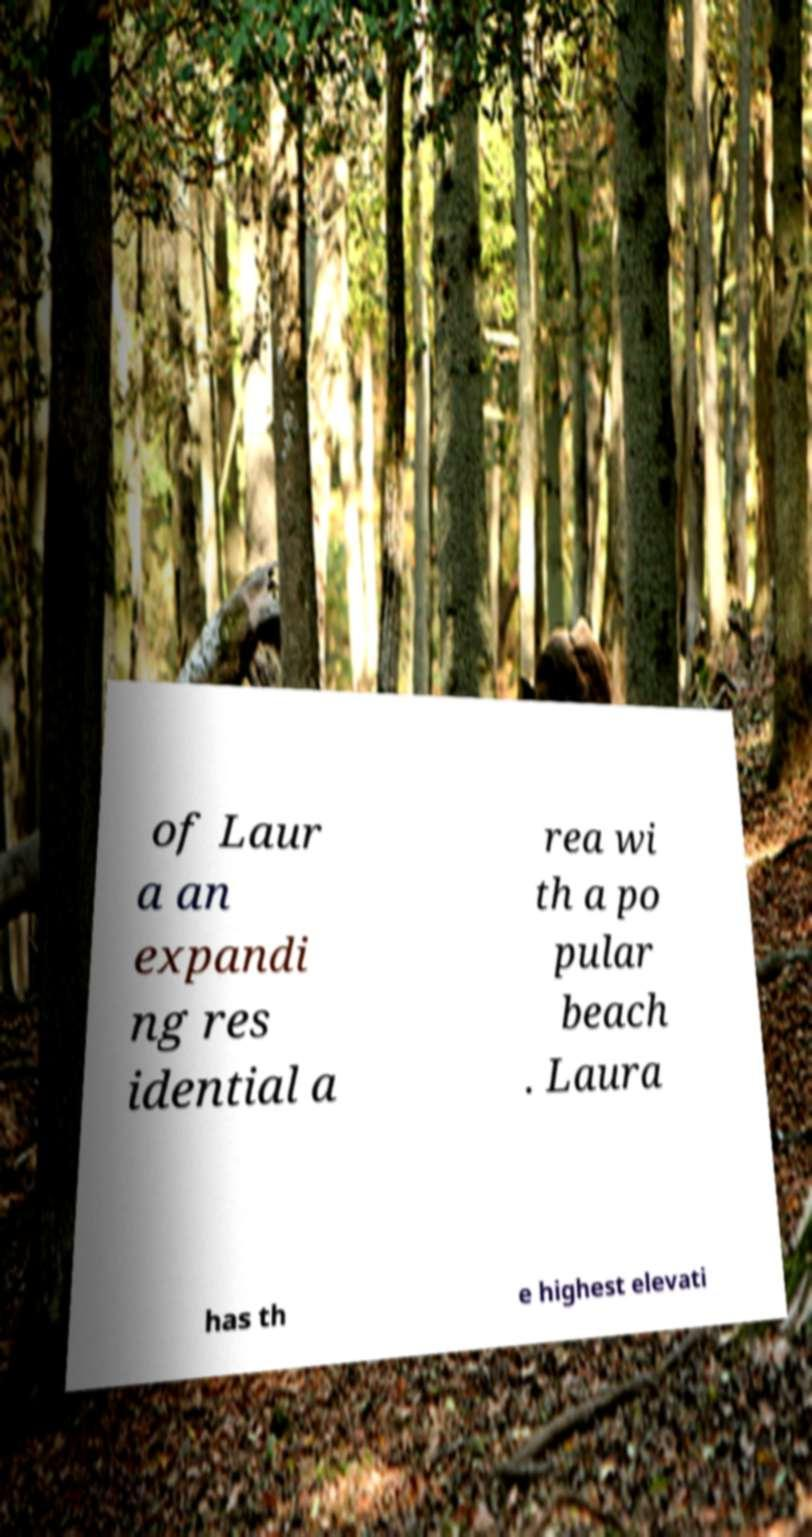Please read and relay the text visible in this image. What does it say? of Laur a an expandi ng res idential a rea wi th a po pular beach . Laura has th e highest elevati 